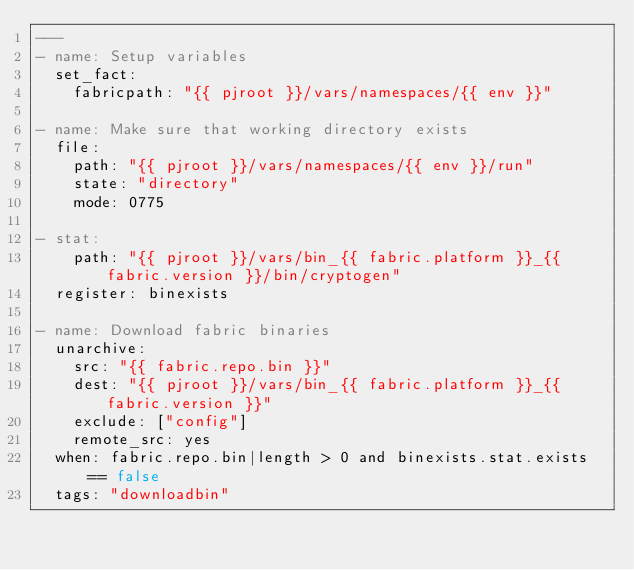<code> <loc_0><loc_0><loc_500><loc_500><_YAML_>---
- name: Setup variables
  set_fact:
    fabricpath: "{{ pjroot }}/vars/namespaces/{{ env }}"

- name: Make sure that working directory exists
  file:
    path: "{{ pjroot }}/vars/namespaces/{{ env }}/run"
    state: "directory"
    mode: 0775

- stat:
    path: "{{ pjroot }}/vars/bin_{{ fabric.platform }}_{{ fabric.version }}/bin/cryptogen"
  register: binexists

- name: Download fabric binaries
  unarchive:
    src: "{{ fabric.repo.bin }}"
    dest: "{{ pjroot }}/vars/bin_{{ fabric.platform }}_{{ fabric.version }}"
    exclude: ["config"]
    remote_src: yes
  when: fabric.repo.bin|length > 0 and binexists.stat.exists == false
  tags: "downloadbin"
</code> 